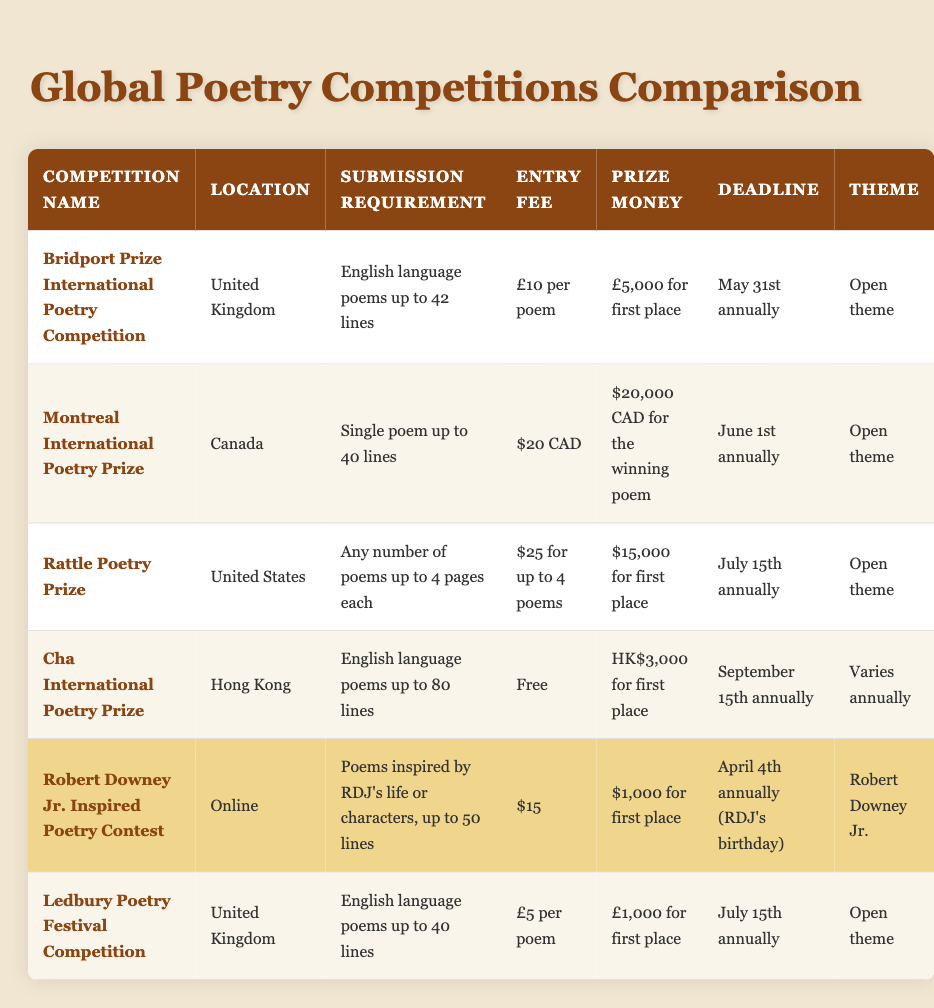What is the entry fee for the Rattle Poetry Prize? The Rattle Poetry Prize has an entry fee listed in the table. Looking at the corresponding row, it states that the fee is $25 for up to 4 poems submitted.
Answer: $25 for up to 4 poems Which competition has the highest prize money? The table provides the prize money for each competition. By comparing the values, the Montreal International Poetry Prize offers the highest amount at $20,000 CAD for the winning poem.
Answer: $20,000 CAD Do all competitions have an international eligibility? The table indicates whether international participants can enter each competition. All competitions listed state "Yes" for international eligibility, confirming that they are open to participants from other countries.
Answer: Yes What is the deadline for submitting poems to the Robert Downey Jr. Inspired Poetry Contest? The deadline is specified in the table for each competition. For the Robert Downey Jr. Inspired Poetry Contest, it is April 4th annually, which is also Robert Downey Jr.'s birthday.
Answer: April 4th How much prize money can one potentially win in the Cha International Poetry Prize? The table shows that the prize money for the Cha International Poetry Prize is HK$3,000 for first place. Thus, this is the amount one could win if awarded first.
Answer: HK$3,000 What is the average entry fee for the competitions listed? To find the average, first extract the entry fees: £10, $20 CAD, $25, Free, $15, and £5. Convert all entries to a consistent currency (using an exchange rate if known) or focus on their values. Summing them gives a total and dividing by the count (6). However, as some data is in free currency, a more precise calculation wouldn’t be accurate without conversion. Therefore, it can be noted that the average may not be straightforward due to the mix of currencies.
Answer: Not directly calculable Is there a competition that allows free submissions? The question relates to the entry fees listed in the table for each competition. It states that the Cha International Poetry Prize has a submission fee of "Free," indicating that participants can submit without any entry cost.
Answer: Yes Which competitions have an open theme? Looking at the theme column in the table, it indicates that the Bridport Prize International Poetry Competition, Montreal International Poetry Prize, Rattle Poetry Prize, and Ledbury Poetry Festival Competition all have an "Open theme". This means participants can submit poems on any subject.
Answer: 4 competitions What is the maximum line count for poems in the Montreal International Poetry Prize? The submission requirement for the Montreal International Poetry Prize is stated in the table, listing a maximum of 40 lines per poem.
Answer: 40 lines 